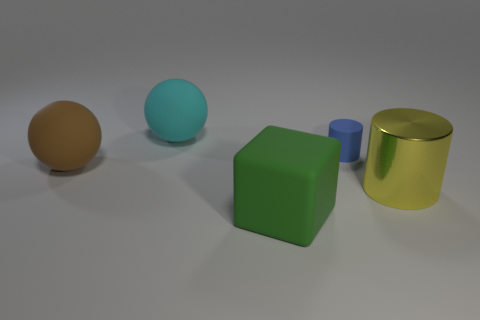Subtract 1 cylinders. How many cylinders are left? 1 Add 3 cyan cylinders. How many objects exist? 8 Subtract all cylinders. How many objects are left? 3 Subtract all blue cylinders. Subtract all red balls. How many cylinders are left? 1 Subtract all brown cylinders. How many brown spheres are left? 1 Subtract all green matte blocks. Subtract all large yellow shiny things. How many objects are left? 3 Add 4 shiny cylinders. How many shiny cylinders are left? 5 Add 1 red metallic objects. How many red metallic objects exist? 1 Subtract 0 brown blocks. How many objects are left? 5 